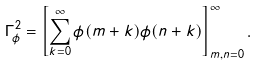<formula> <loc_0><loc_0><loc_500><loc_500>\Gamma _ { \phi } ^ { 2 } = \left [ \sum _ { k = 0 } ^ { \infty } \phi ( m + k ) \phi ( n + k ) \right ] _ { m , n = 0 } ^ { \infty } .</formula> 